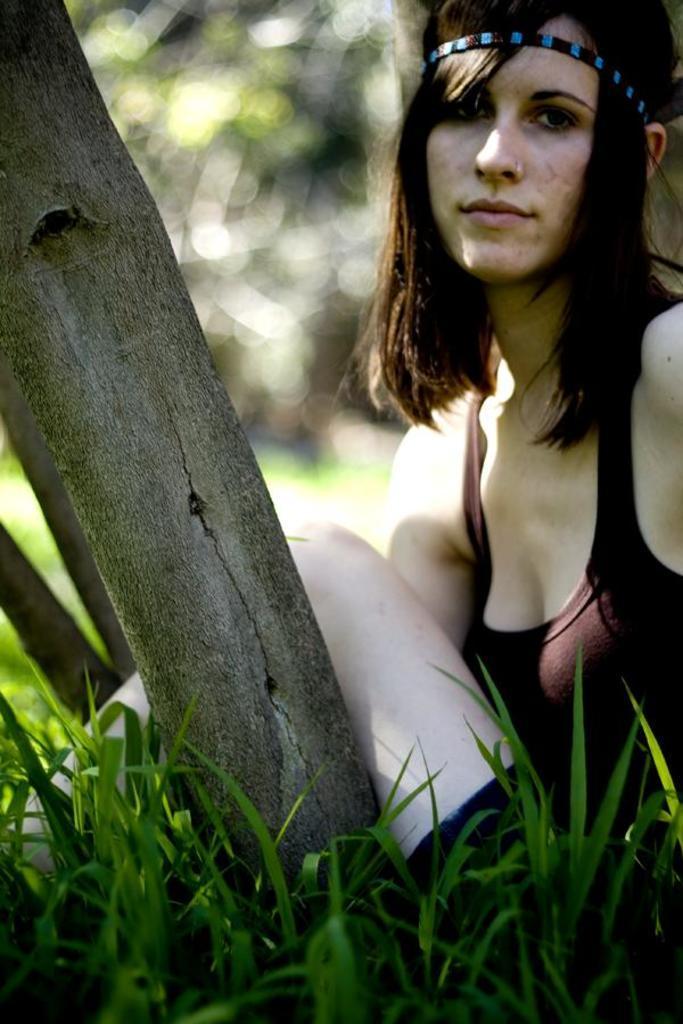How would you summarize this image in a sentence or two? In this image, I can see the woman sitting. She wore a headband and a dress. This is the grass. I think this is the tree trunk. The background looks blurry. 